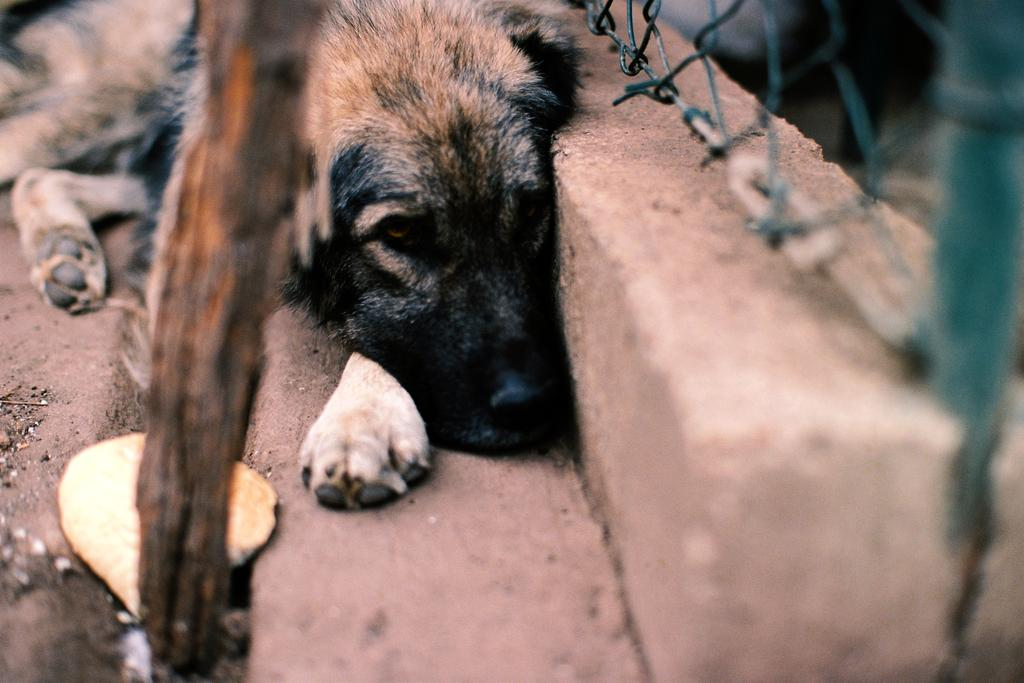What type of animal is in the image? There is a dog in the image. What is the dog doing in the image? The dog is sitting on the ground. What object is on the ground near the dog? There is a stick on the ground. What can be seen on the wall in the top right of the image? There is fencing on the wall in the top right of the image. What type of hill can be seen in the background of the image? There is no hill visible in the image. 